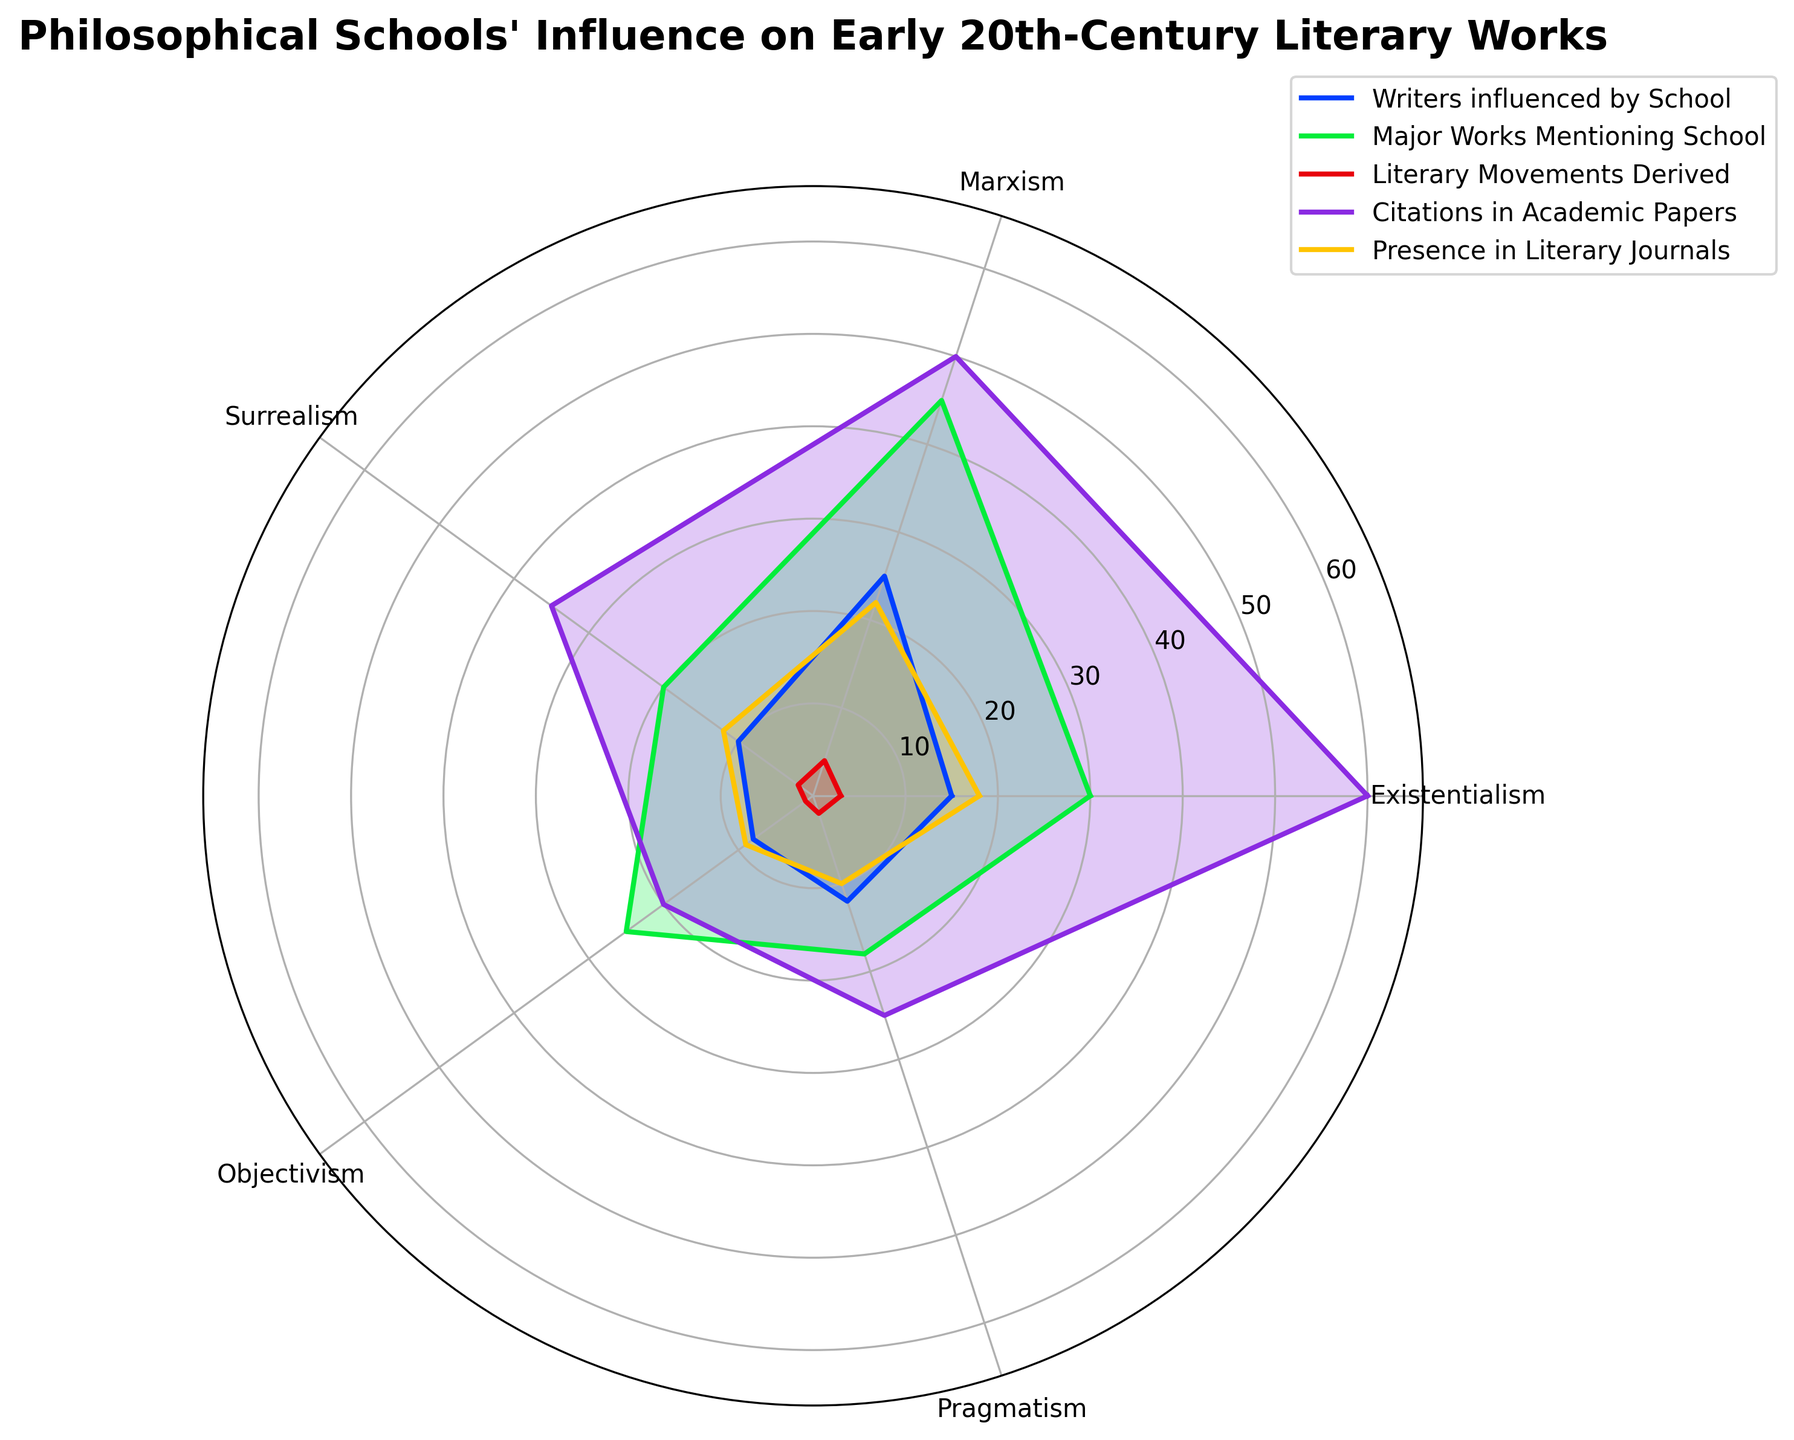What is the title of the plot? The title is located at the top of the plot. By reading it, we can understand the main focus of the plot.
Answer: Philosophical Schools' Influence on Early 20th-Century Literary Works How many categories are presented in the plot? The categories are listed around the circumference of the polar plot. By counting them, we determine the number of dimensions represented.
Answer: Five Which philosophical school influenced the most writers? Look at the 'Writers influenced by School' values and find the one with the highest value. Existentialism has 15, Marxism has 25, Surrealism has 10, Objectivism has 8, and Pragmatism has 12. The highest is Marxism with 25.
Answer: Marxism Which philosophical school has the least presence in literary journals? Refer to the 'Presence in Literary Journals' values. Existentialism has 18, Marxism has 22, Surrealism has 12, Objectivism has 9, and Pragmatism has 10. The lowest is Objectivism with 9.
Answer: Objectivism How many major works mention Objectivism? Locate the 'Major Works Mentioning School' line and find Objectivism's value. Objectivism is represented by a data point that corresponds to 25.
Answer: 25 What is the average number of literary movements derived from all philosophical schools? Sum the 'Literary Movements Derived' values and divide by the number of categories. (3 + 4 + 2 + 1 + 2) = 12, so the average is 12/5 = 2.4
Answer: 2.4 Which philosophical school has more citations in academic papers, Existentialism or Surrealism? Existentialism has 60 citations, and Surrealism has 35 citations. By comparing these values, Existentialism has more citations.
Answer: Existentialism Is the number of writers influenced by Surrealism greater than those by Pragmatism? Surrealism influences 10 writers, while Pragmatism influences 12 writers. Pragmatism influences more writers than Surrealism.
Answer: No What is the difference between the number of major works mentioning Marxism and Existentialism? Marxism has 45 major works mentioning it, while Existentialism has 30. The difference is 45 - 30 = 15.
Answer: 15 Which philosophical school has the lowest value in any of the categories and what is it? Objectivism has the lowest value in 'Literary Movements Derived,' with a value of 1. It is the minimum compared across all categories and data points.
Answer: Objectivism, 1 